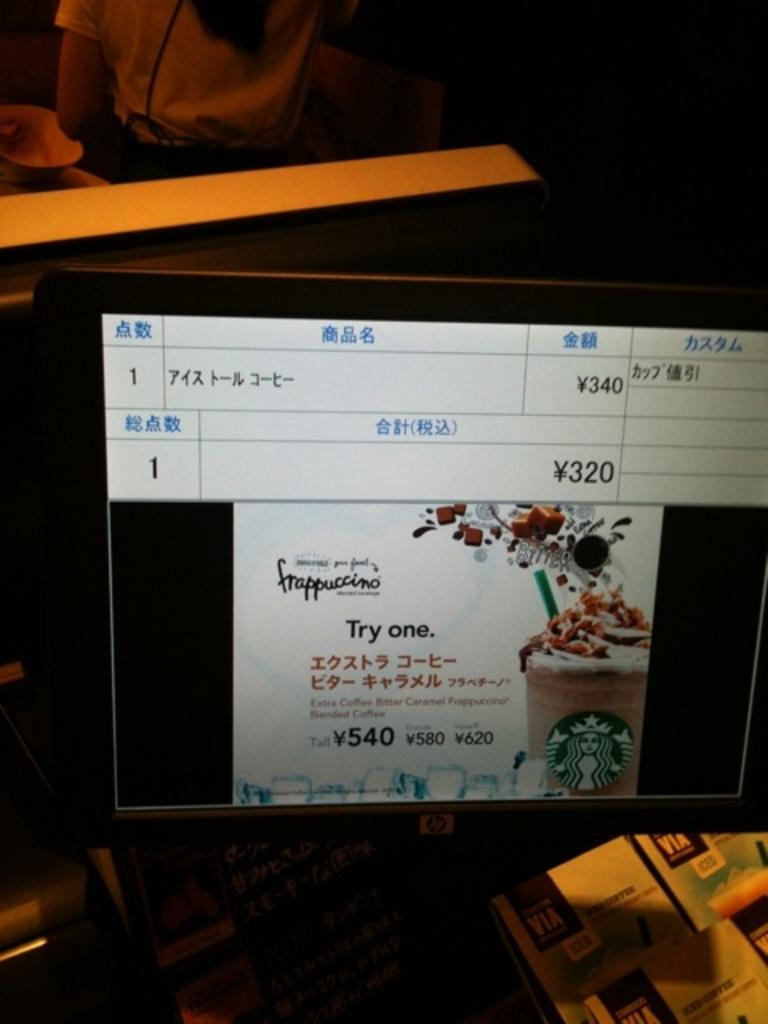<image>
Provide a brief description of the given image. Screen that has the number 320 and 340 on it. 